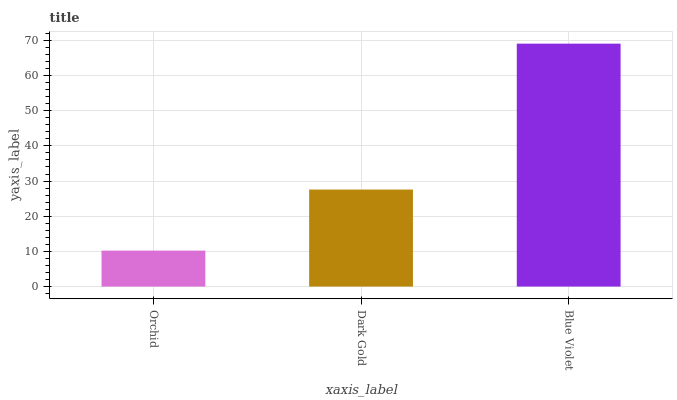Is Orchid the minimum?
Answer yes or no. Yes. Is Blue Violet the maximum?
Answer yes or no. Yes. Is Dark Gold the minimum?
Answer yes or no. No. Is Dark Gold the maximum?
Answer yes or no. No. Is Dark Gold greater than Orchid?
Answer yes or no. Yes. Is Orchid less than Dark Gold?
Answer yes or no. Yes. Is Orchid greater than Dark Gold?
Answer yes or no. No. Is Dark Gold less than Orchid?
Answer yes or no. No. Is Dark Gold the high median?
Answer yes or no. Yes. Is Dark Gold the low median?
Answer yes or no. Yes. Is Orchid the high median?
Answer yes or no. No. Is Orchid the low median?
Answer yes or no. No. 